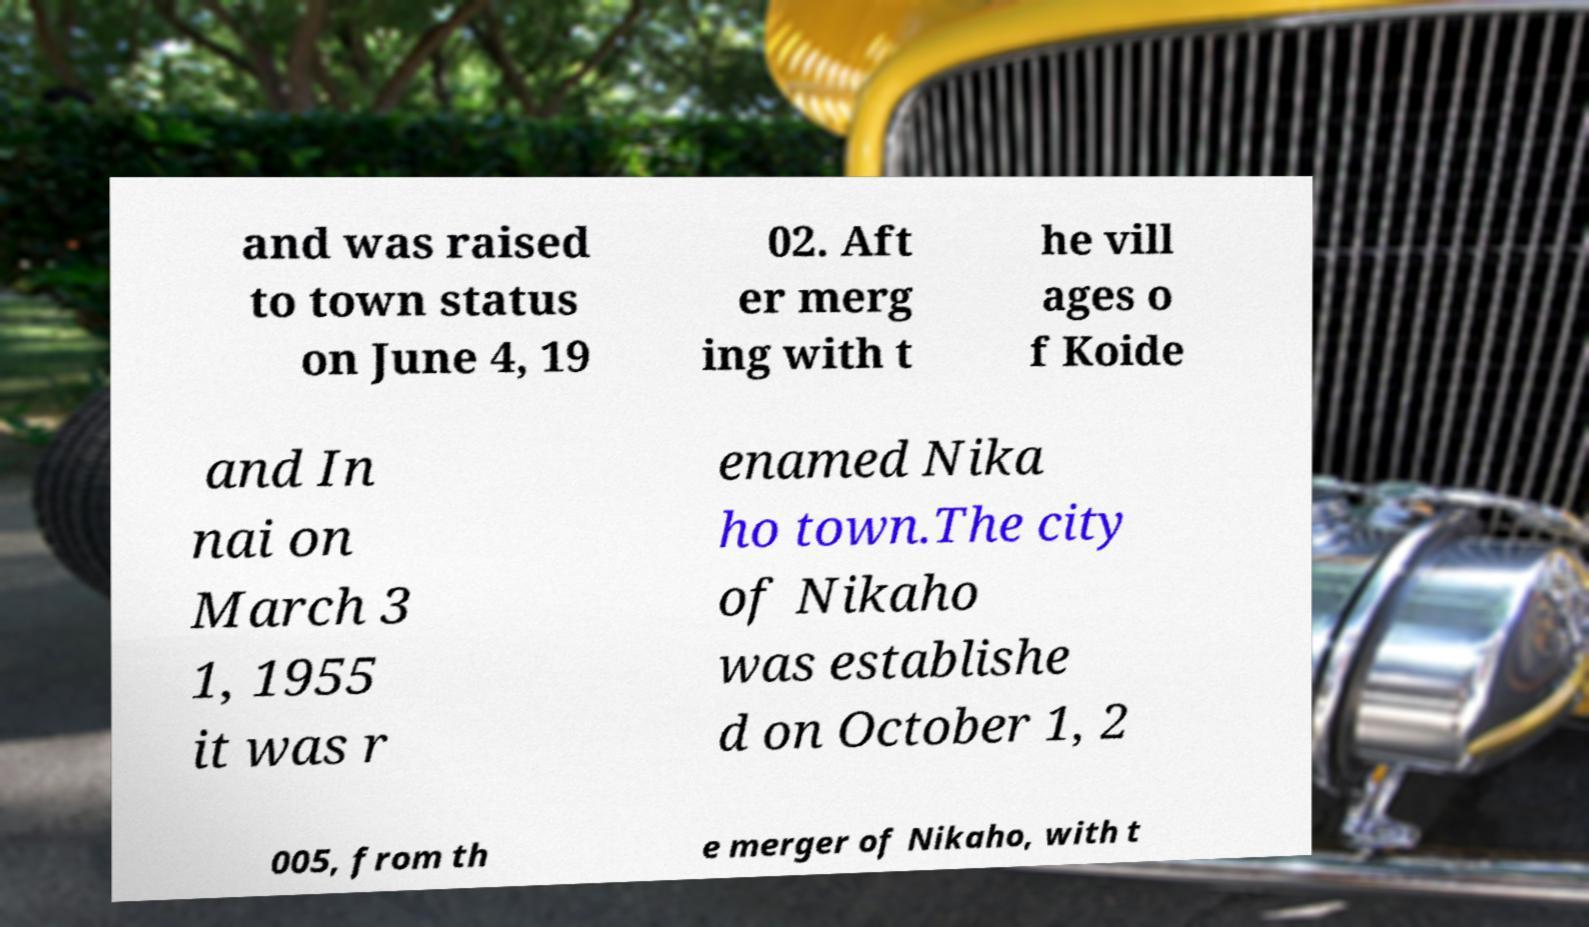Please identify and transcribe the text found in this image. and was raised to town status on June 4, 19 02. Aft er merg ing with t he vill ages o f Koide and In nai on March 3 1, 1955 it was r enamed Nika ho town.The city of Nikaho was establishe d on October 1, 2 005, from th e merger of Nikaho, with t 